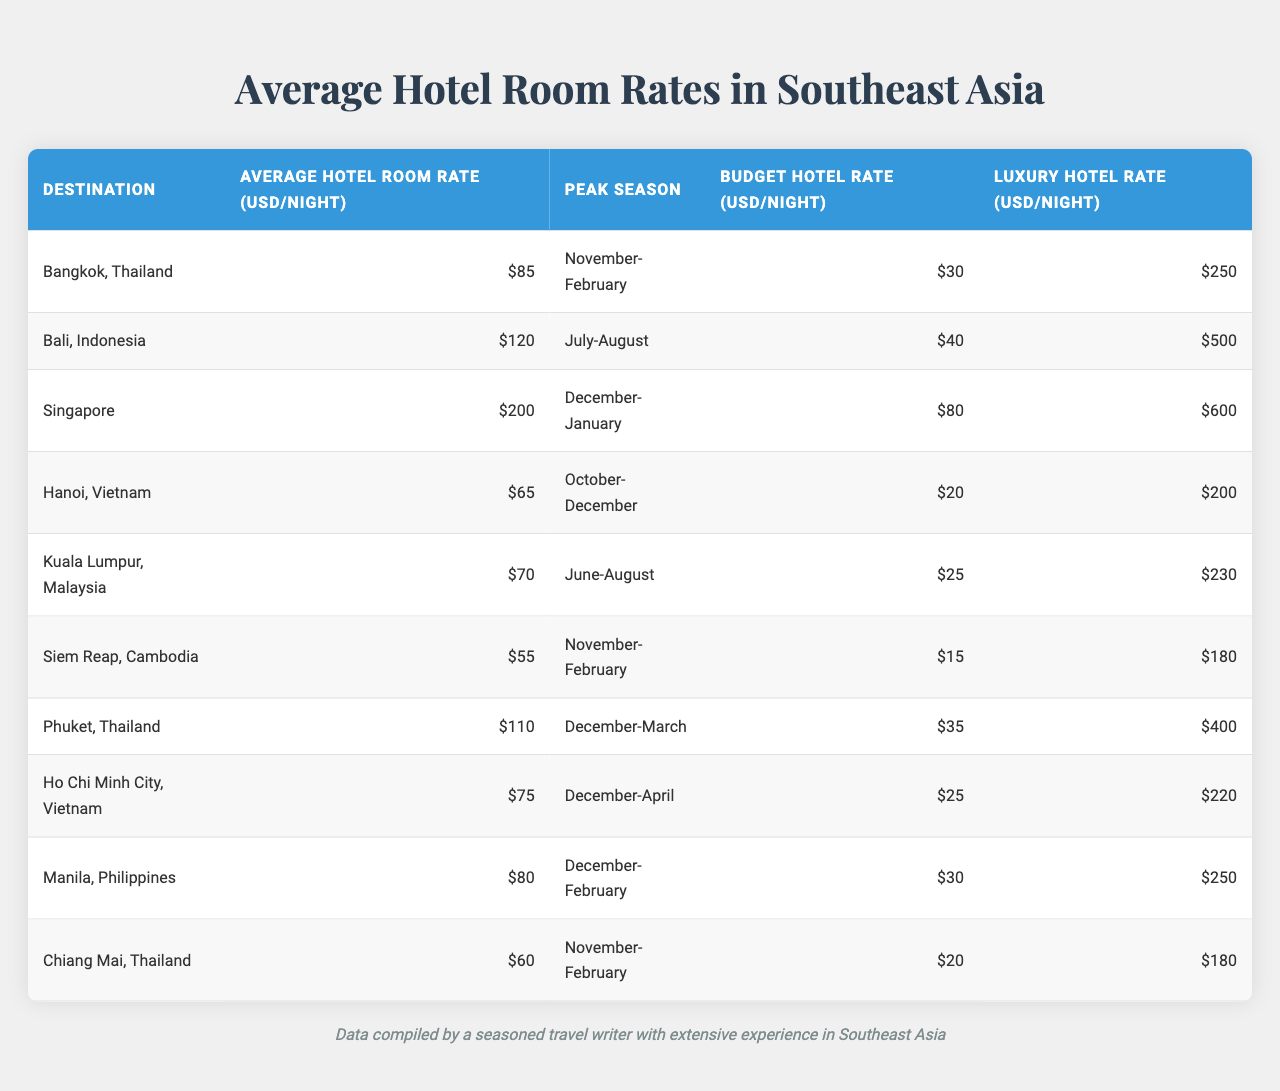What is the average hotel room rate in Bangkok, Thailand? The table shows that the average hotel room rate in Bangkok, Thailand, is listed as 85 USD per night.
Answer: 85 USD Which destination has the highest average hotel room rate? By looking at the data, Singapore has the highest average hotel room rate at 200 USD per night.
Answer: Singapore What is the peak season for hotel rates in Bali, Indonesia? The table indicates that the peak season for Bali, Indonesia, is during July-August.
Answer: July-August What is the difference between the luxury hotel rate and the budget hotel rate in Ho Chi Minh City, Vietnam? The luxury hotel rate is 220 USD, and the budget hotel rate is 25 USD. The difference is 220 - 25 = 195 USD.
Answer: 195 USD In which city can you find the lowest average hotel room rate? The table shows that Siem Reap, Cambodia, has the lowest average hotel room rate at 55 USD per night.
Answer: Siem Reap, Cambodia What is the average price of a luxury hotel room across all listed destinations? The luxury hotel rates are 250, 500, 600, 200, 230, 180, 400, 220, 250, and 180 USD. Summing these values gives 2810 USD, and dividing by 10 (number of destinations) results in an average of 281 USD.
Answer: 281 USD Is the average hotel room rate in Phuket higher than in Kuala Lumpur? The average hotel rate in Phuket is 110 USD, while in Kuala Lumpur, it is 70 USD. Since 110 is greater than 70, the statement is true.
Answer: Yes What is the average hotel room rate for destinations with a peak season in December? The destinations with a peak season in December are Singapore (200 USD), Ho Chi Minh City (75 USD), and Manila (80 USD). The average rate is (200 + 75 + 80) / 3 = 118.33 USD.
Answer: 118.33 USD Which destination offers the most budget-friendly hotel options? Looking at the budget rates in the table, Siem Reap, Cambodia, has the lowest budget hotel rate at 15 USD per night.
Answer: Siem Reap, Cambodia What is the total average hotel room rate for all destinations during their peak seasons? The average hotel room rates during the peak seasons are 85 (Bangkok) + 120 (Bali) + 200 (Singapore) + 65 (Hanoi) + 70 (Kuala Lumpur) + 55 (Siem Reap) + 110 (Phuket) + 75 (Ho Chi Minh) + 80 (Manila) + 60 (Chiang Mai) =  1,335 USD across 10 destinations, resulting in an average of 133.50 USD.
Answer: 133.50 USD 